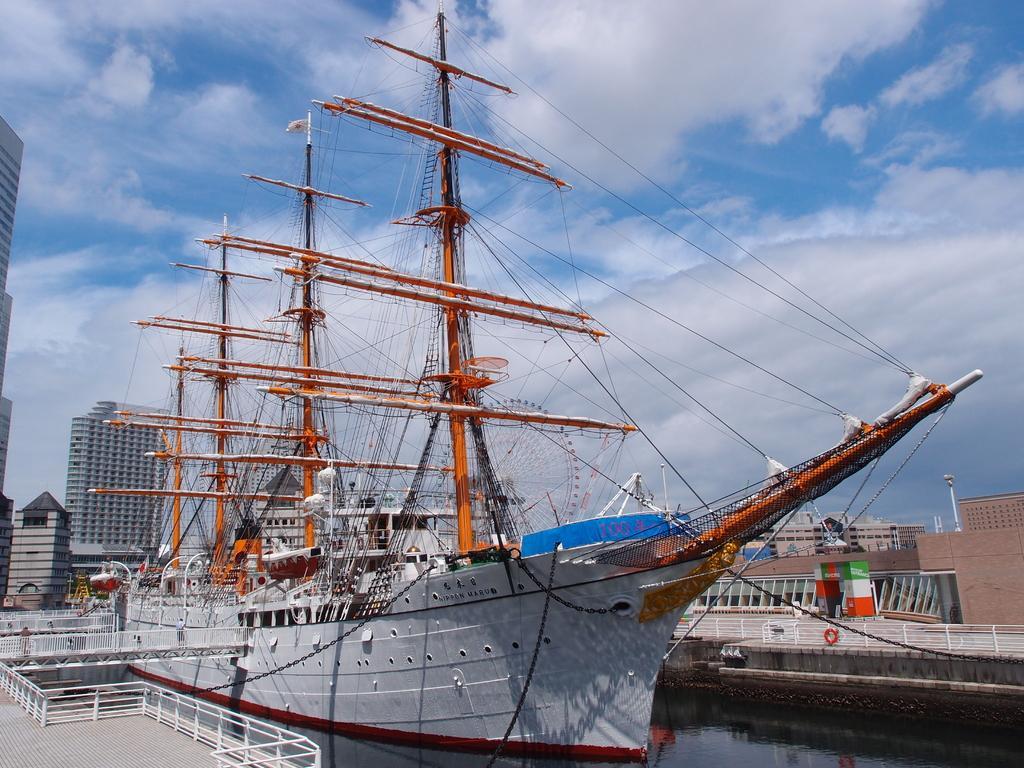In one or two sentences, can you explain what this image depicts? In this image I can see the boat on the water. The boat is in white and brown color. To the side of the boat I can see the railing. In the background there are buildings, clouds and the sky. 